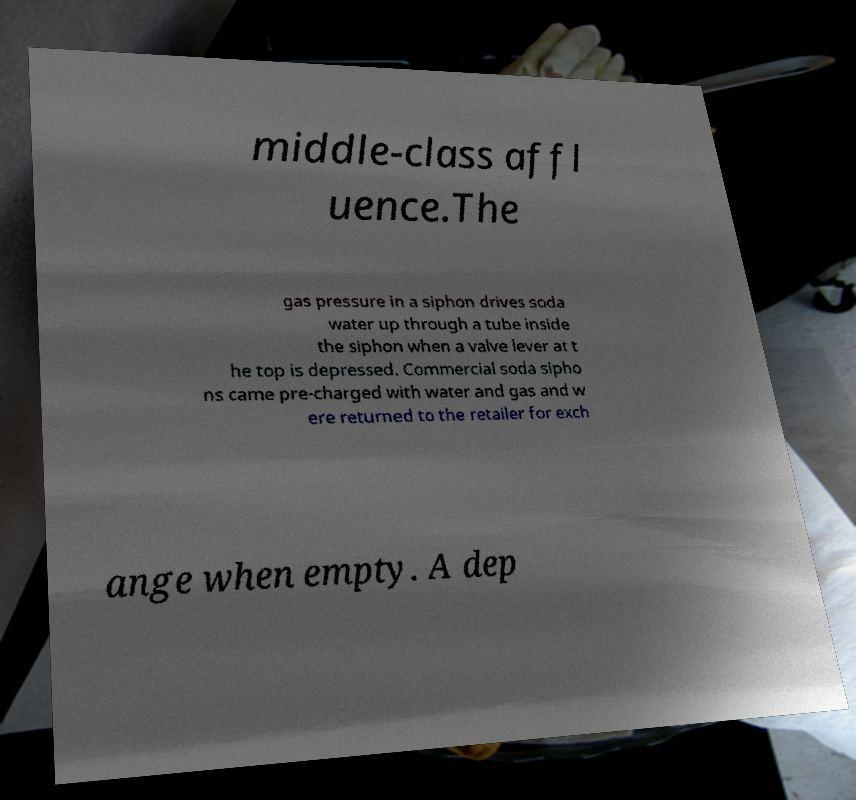I need the written content from this picture converted into text. Can you do that? middle-class affl uence.The gas pressure in a siphon drives soda water up through a tube inside the siphon when a valve lever at t he top is depressed. Commercial soda sipho ns came pre-charged with water and gas and w ere returned to the retailer for exch ange when empty. A dep 